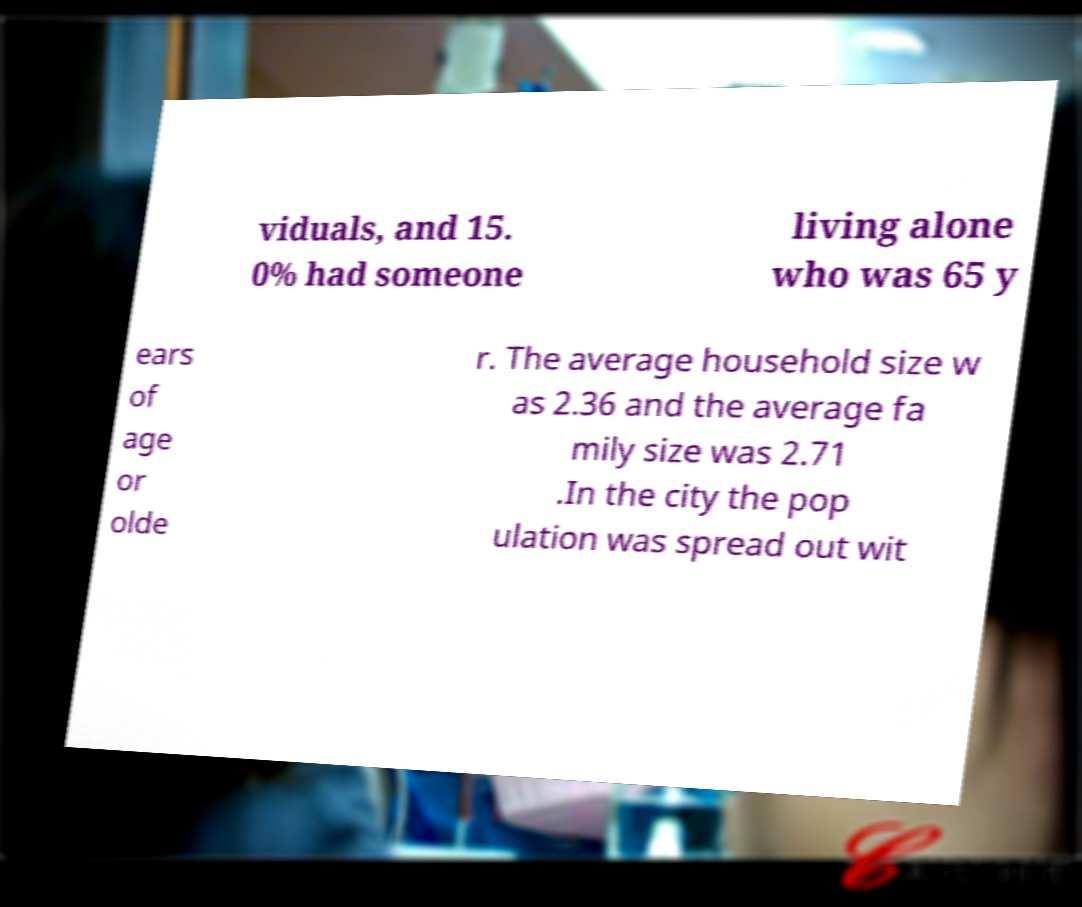Could you assist in decoding the text presented in this image and type it out clearly? viduals, and 15. 0% had someone living alone who was 65 y ears of age or olde r. The average household size w as 2.36 and the average fa mily size was 2.71 .In the city the pop ulation was spread out wit 